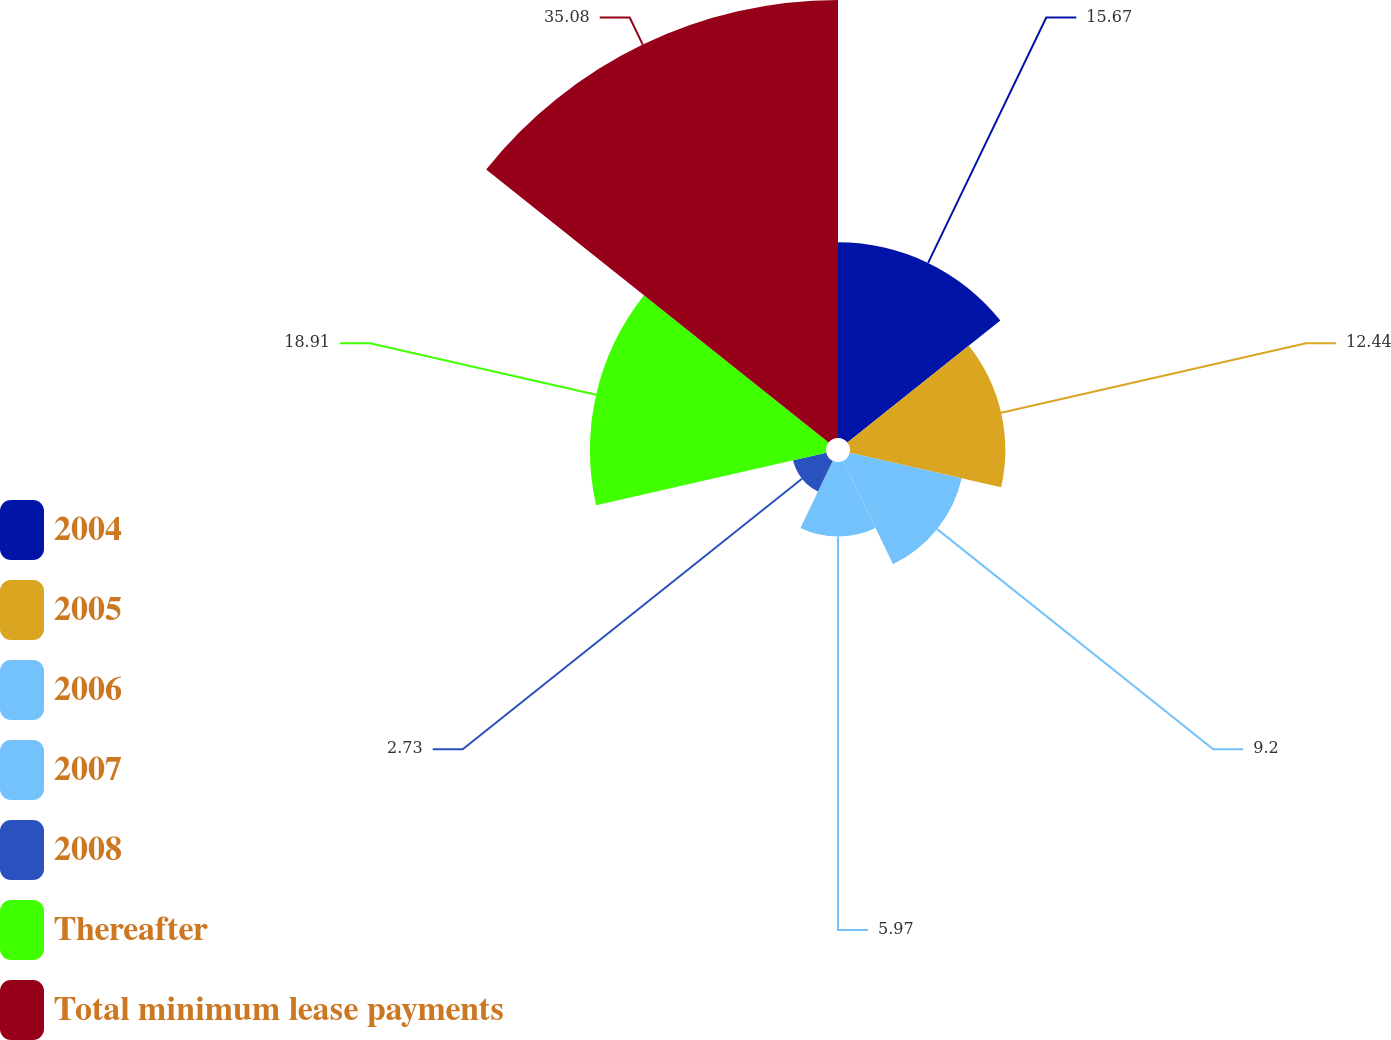Convert chart. <chart><loc_0><loc_0><loc_500><loc_500><pie_chart><fcel>2004<fcel>2005<fcel>2006<fcel>2007<fcel>2008<fcel>Thereafter<fcel>Total minimum lease payments<nl><fcel>15.67%<fcel>12.44%<fcel>9.2%<fcel>5.97%<fcel>2.73%<fcel>18.91%<fcel>35.08%<nl></chart> 